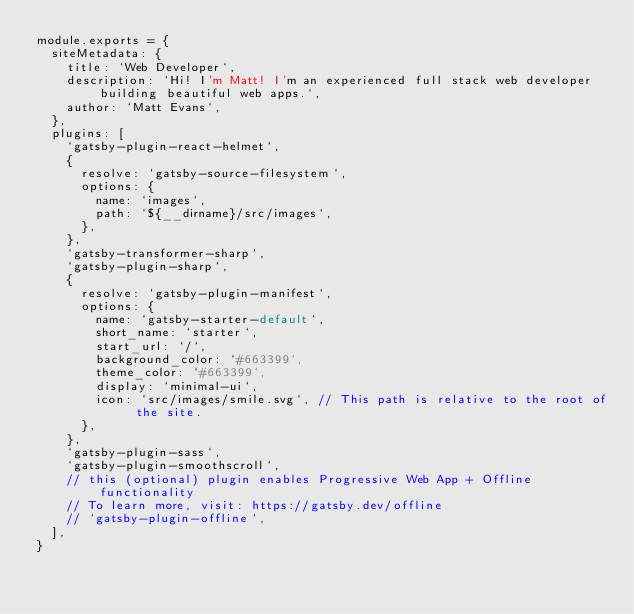Convert code to text. <code><loc_0><loc_0><loc_500><loc_500><_JavaScript_>module.exports = {
  siteMetadata: {
    title: `Web Developer`,
    description: `Hi! I'm Matt! I'm an experienced full stack web developer building beautiful web apps.`,
    author: `Matt Evans`,
  },
  plugins: [
    `gatsby-plugin-react-helmet`,
    {
      resolve: `gatsby-source-filesystem`,
      options: {
        name: `images`,
        path: `${__dirname}/src/images`,
      },
    },
    `gatsby-transformer-sharp`,
    `gatsby-plugin-sharp`,
    {
      resolve: `gatsby-plugin-manifest`,
      options: {
        name: `gatsby-starter-default`,
        short_name: `starter`,
        start_url: `/`,
        background_color: `#663399`,
        theme_color: `#663399`,
        display: `minimal-ui`,
        icon: `src/images/smile.svg`, // This path is relative to the root of the site.
      },
    },
    `gatsby-plugin-sass`,
    `gatsby-plugin-smoothscroll`,
    // this (optional) plugin enables Progressive Web App + Offline functionality
    // To learn more, visit: https://gatsby.dev/offline
    // `gatsby-plugin-offline`,
  ],
}
</code> 